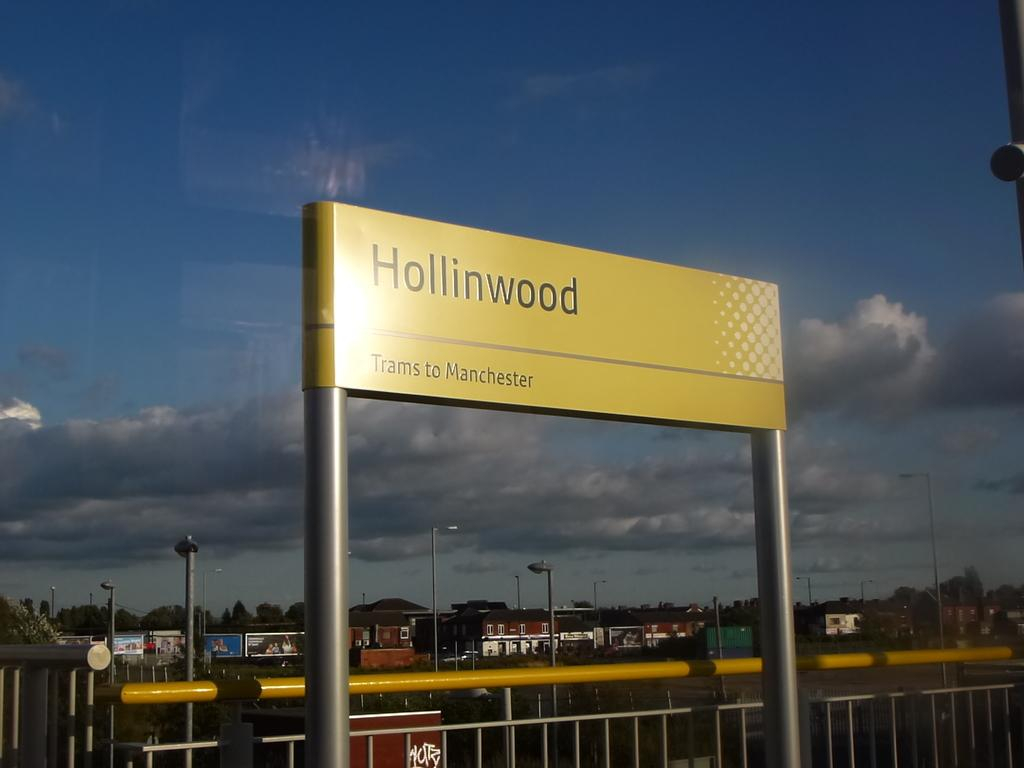<image>
Render a clear and concise summary of the photo. a street sign with the word Hollinwood written across 